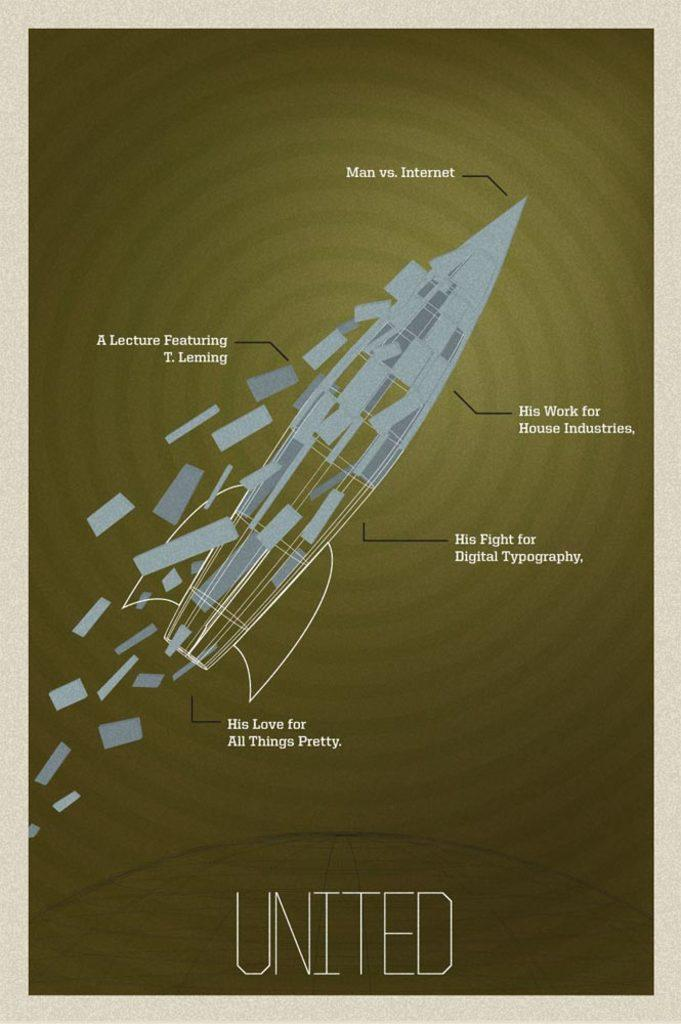<image>
Present a compact description of the photo's key features. A poster for a lecture featuring T. Lemming. 